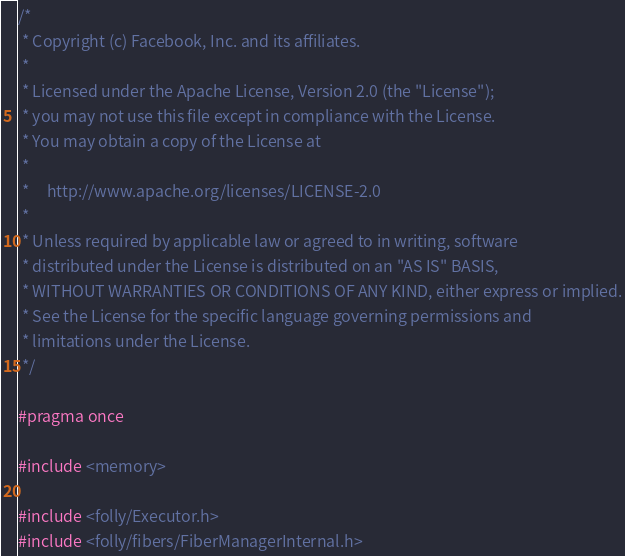Convert code to text. <code><loc_0><loc_0><loc_500><loc_500><_C_>/*
 * Copyright (c) Facebook, Inc. and its affiliates.
 *
 * Licensed under the Apache License, Version 2.0 (the "License");
 * you may not use this file except in compliance with the License.
 * You may obtain a copy of the License at
 *
 *     http://www.apache.org/licenses/LICENSE-2.0
 *
 * Unless required by applicable law or agreed to in writing, software
 * distributed under the License is distributed on an "AS IS" BASIS,
 * WITHOUT WARRANTIES OR CONDITIONS OF ANY KIND, either express or implied.
 * See the License for the specific language governing permissions and
 * limitations under the License.
 */

#pragma once

#include <memory>

#include <folly/Executor.h>
#include <folly/fibers/FiberManagerInternal.h></code> 